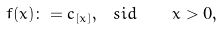<formula> <loc_0><loc_0><loc_500><loc_500>f ( x ) \colon = c _ { [ x ] } , \ s i d { \quad x > 0 , }</formula> 